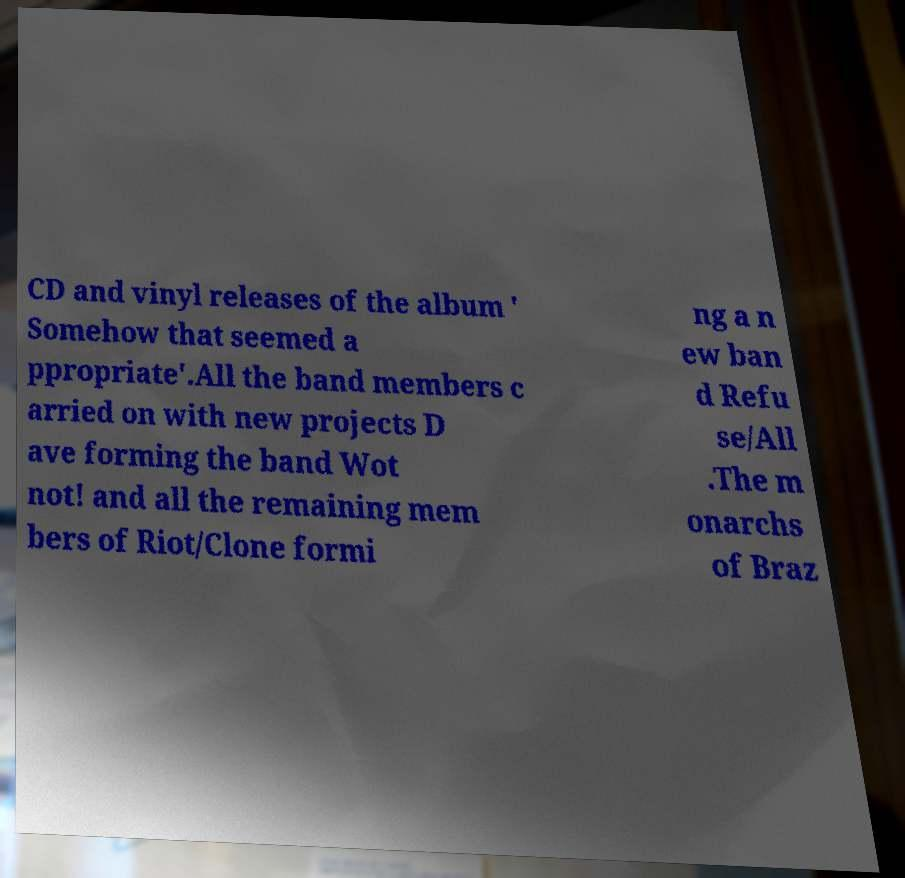Can you accurately transcribe the text from the provided image for me? CD and vinyl releases of the album ' Somehow that seemed a ppropriate'.All the band members c arried on with new projects D ave forming the band Wot not! and all the remaining mem bers of Riot/Clone formi ng a n ew ban d Refu se/All .The m onarchs of Braz 